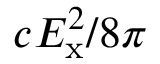<formula> <loc_0><loc_0><loc_500><loc_500>c E _ { x } ^ { 2 } / 8 \pi</formula> 